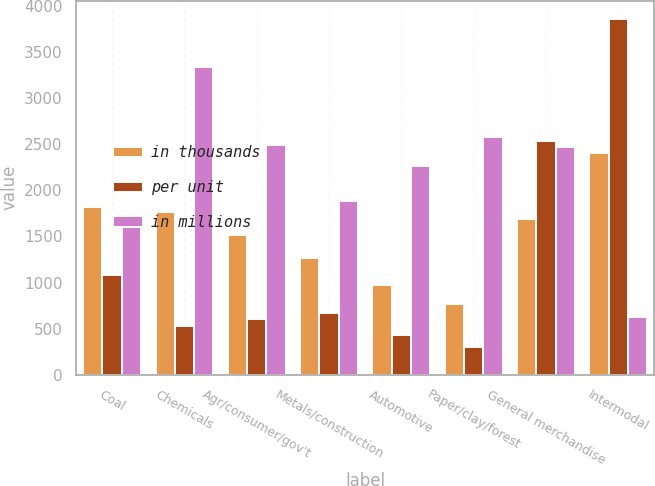Convert chart. <chart><loc_0><loc_0><loc_500><loc_500><stacked_bar_chart><ecel><fcel>Coal<fcel>Chemicals<fcel>Agr/consumer/gov't<fcel>Metals/construction<fcel>Automotive<fcel>Paper/clay/forest<fcel>General merchandise<fcel>Intermodal<nl><fcel>in thousands<fcel>1823<fcel>1760<fcel>1516<fcel>1263<fcel>969<fcel>771<fcel>1688<fcel>2409<nl><fcel>per unit<fcel>1079.7<fcel>527.6<fcel>609<fcel>672.4<fcel>429.3<fcel>299.9<fcel>2538.2<fcel>3861<nl><fcel>in millions<fcel>1688<fcel>3335<fcel>2489<fcel>1879<fcel>2258<fcel>2573<fcel>2474<fcel>624<nl></chart> 